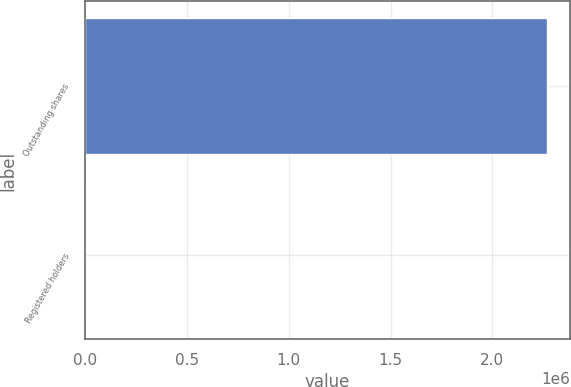<chart> <loc_0><loc_0><loc_500><loc_500><bar_chart><fcel>Outstanding shares<fcel>Registered holders<nl><fcel>2.26781e+06<fcel>1<nl></chart> 